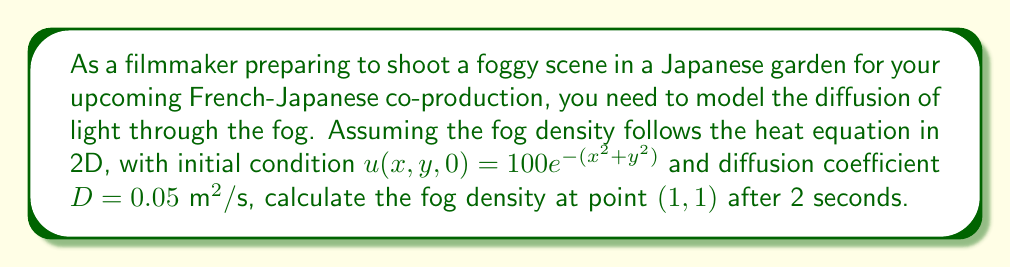Provide a solution to this math problem. To solve this problem, we'll use the heat equation in 2D:

$$\frac{\partial u}{\partial t} = D\left(\frac{\partial^2 u}{\partial x^2} + \frac{\partial^2 u}{\partial y^2}\right)$$

Given:
- Initial condition: $u(x,y,0) = 100e^{-(x^2+y^2)}$
- Diffusion coefficient: $D = 0.05 \text{ m}^2/\text{s}$
- Point of interest: $(x,y) = (1,1)$
- Time: $t = 2\text{ s}$

The solution to the 2D heat equation with an initial Gaussian distribution is:

$$u(x,y,t) = \frac{100}{1+4Dt} \exp\left(-\frac{x^2+y^2}{1+4Dt}\right)$$

Steps to solve:
1. Substitute the given values into the solution:
   $t = 2\text{ s}$
   $D = 0.05 \text{ m}^2/\text{s}$
   $x = 1$
   $y = 1$

2. Calculate $1+4Dt$:
   $1+4Dt = 1 + 4(0.05)(2) = 1.4$

3. Calculate the exponent:
   $-\frac{x^2+y^2}{1+4Dt} = -\frac{1^2+1^2}{1.4} = -\frac{2}{1.4} \approx -1.4286$

4. Substitute into the solution:
   $$u(1,1,2) = \frac{100}{1.4} \exp(-1.4286)$$

5. Calculate the final result:
   $$u(1,1,2) \approx 71.4286 \times 0.2395 \approx 17.1071$$
Answer: The fog density at point (1,1) after 2 seconds is approximately 17.1071 units. 